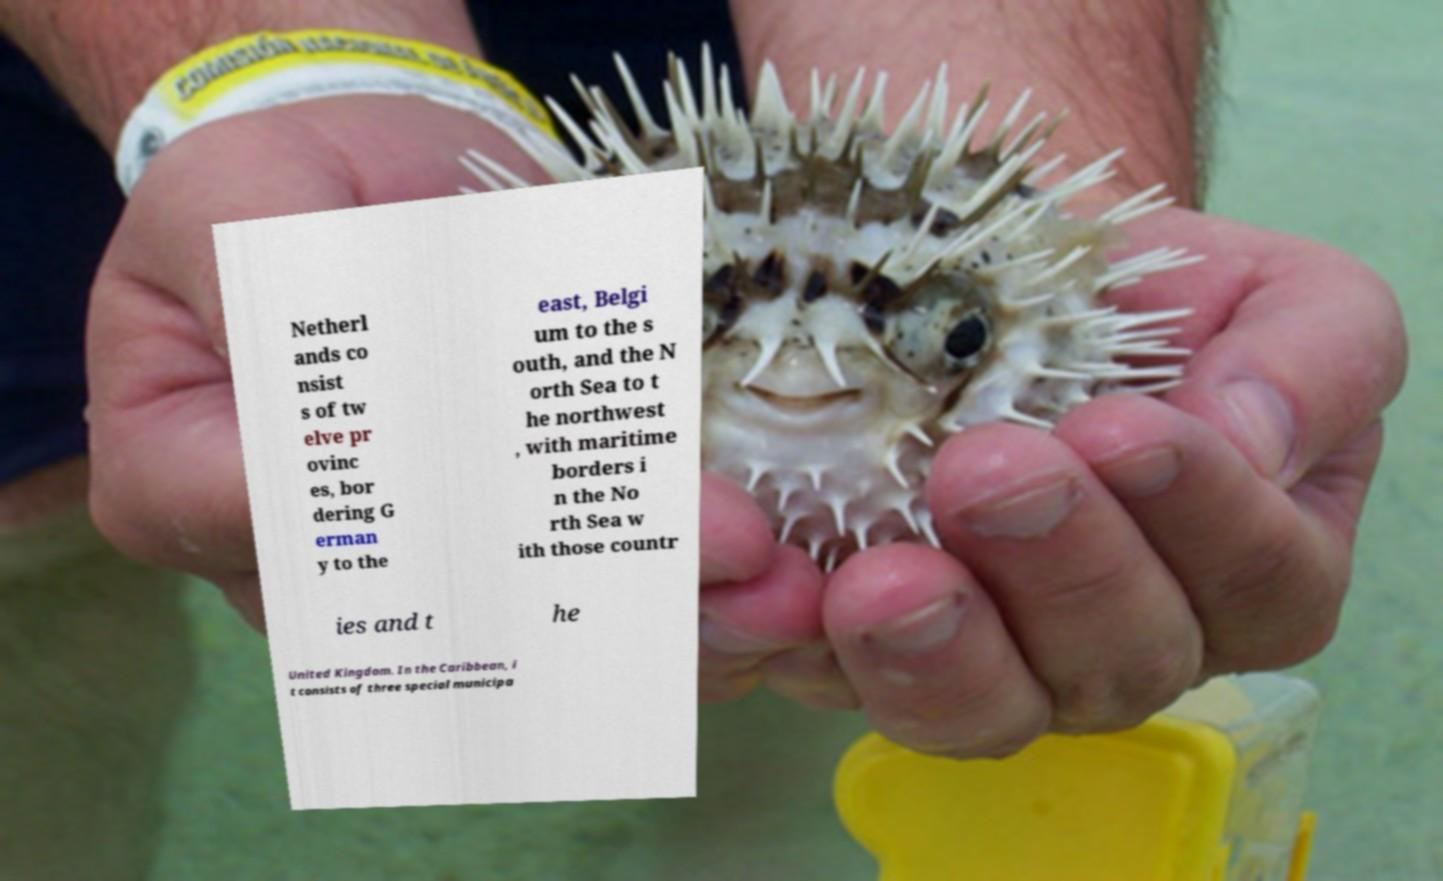What messages or text are displayed in this image? I need them in a readable, typed format. Netherl ands co nsist s of tw elve pr ovinc es, bor dering G erman y to the east, Belgi um to the s outh, and the N orth Sea to t he northwest , with maritime borders i n the No rth Sea w ith those countr ies and t he United Kingdom. In the Caribbean, i t consists of three special municipa 